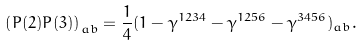Convert formula to latex. <formula><loc_0><loc_0><loc_500><loc_500>\left ( P ( 2 ) P ( 3 ) \right ) _ { a b } = \frac { 1 } { 4 } ( 1 - \gamma ^ { 1 2 3 4 } - \gamma ^ { 1 2 5 6 } - \gamma ^ { 3 4 5 6 } ) _ { a b } .</formula> 